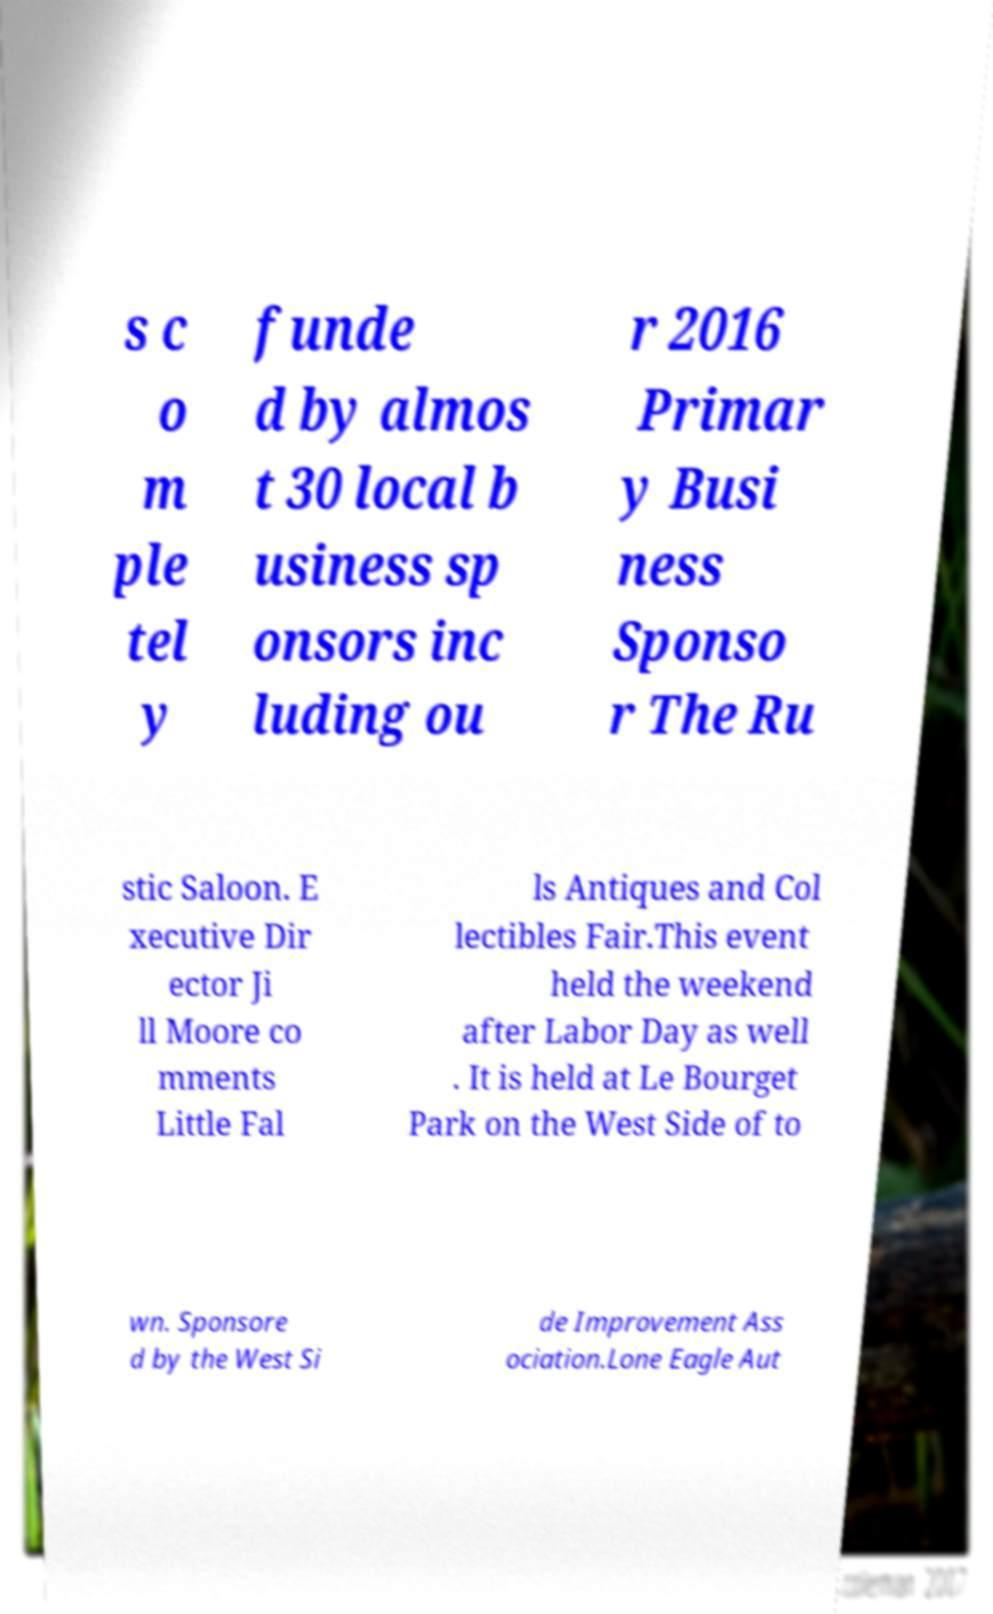Can you accurately transcribe the text from the provided image for me? s c o m ple tel y funde d by almos t 30 local b usiness sp onsors inc luding ou r 2016 Primar y Busi ness Sponso r The Ru stic Saloon. E xecutive Dir ector Ji ll Moore co mments Little Fal ls Antiques and Col lectibles Fair.This event held the weekend after Labor Day as well . It is held at Le Bourget Park on the West Side of to wn. Sponsore d by the West Si de Improvement Ass ociation.Lone Eagle Aut 